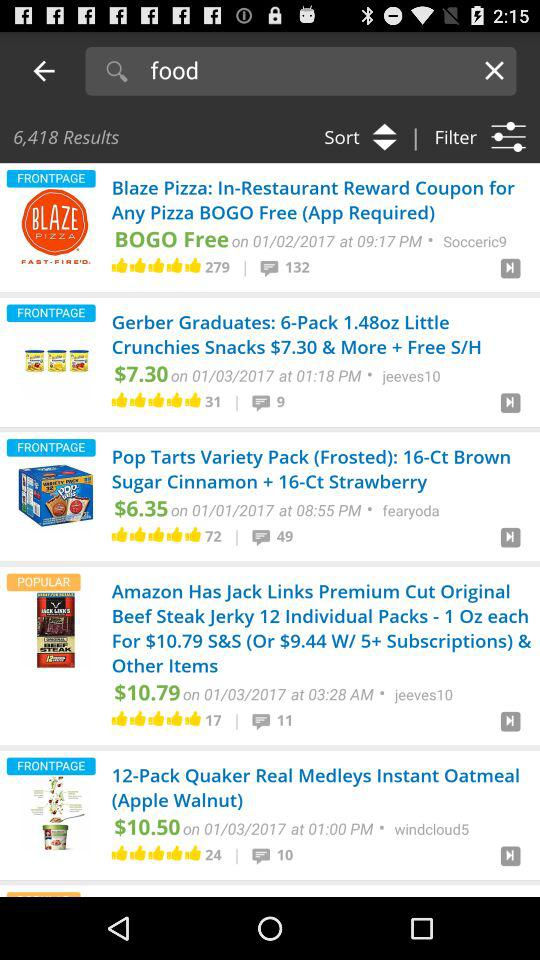How many likes did "Blaze Pizza" get? "Blaze Pizza" got 279 likes. 